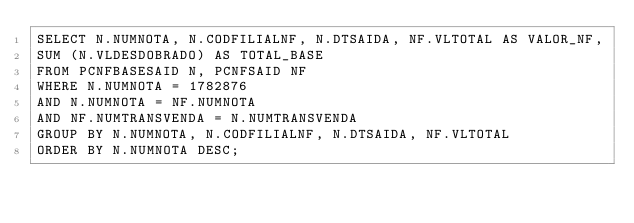Convert code to text. <code><loc_0><loc_0><loc_500><loc_500><_SQL_>SELECT N.NUMNOTA, N.CODFILIALNF, N.DTSAIDA, NF.VLTOTAL AS VALOR_NF,
SUM (N.VLDESDOBRADO) AS TOTAL_BASE
FROM PCNFBASESAID N, PCNFSAID NF 
WHERE N.NUMNOTA = 1782876
AND N.NUMNOTA = NF.NUMNOTA
AND NF.NUMTRANSVENDA = N.NUMTRANSVENDA
GROUP BY N.NUMNOTA, N.CODFILIALNF, N.DTSAIDA, NF.VLTOTAL
ORDER BY N.NUMNOTA DESC;</code> 